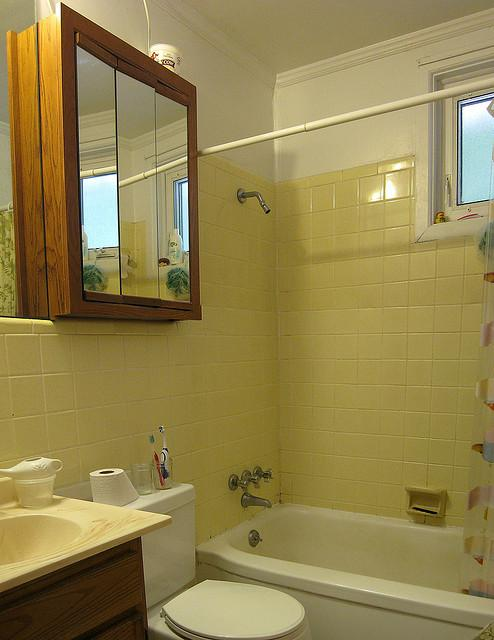What happens behind the curtain? Please explain your reasoning. cleaning. The curtains have to be cleaned. 